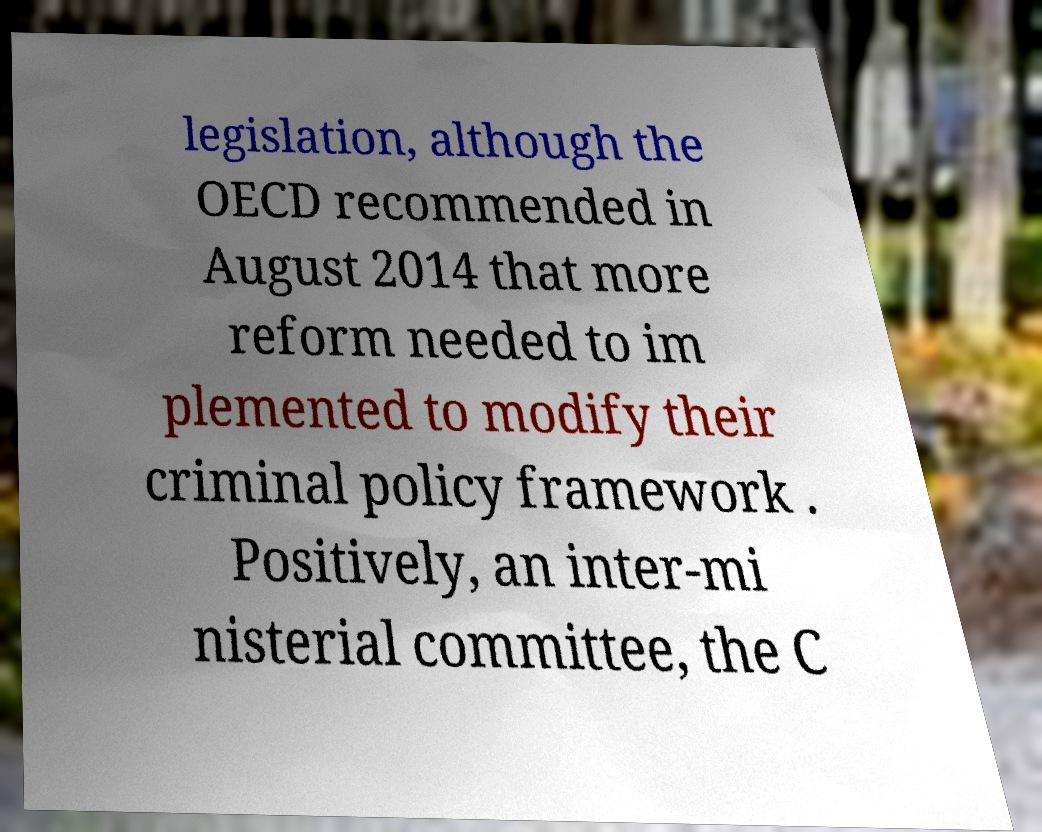There's text embedded in this image that I need extracted. Can you transcribe it verbatim? legislation, although the OECD recommended in August 2014 that more reform needed to im plemented to modify their criminal policy framework . Positively, an inter-mi nisterial committee, the C 